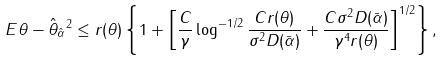Convert formula to latex. <formula><loc_0><loc_0><loc_500><loc_500>E \| \theta - \hat { \theta } _ { \hat { \alpha } } \| ^ { 2 } \leq r ( \theta ) \left \{ 1 + \left [ \frac { C } { \gamma } \log ^ { - 1 / 2 } \frac { C r ( \theta ) } { \sigma ^ { 2 } D ( \bar { \alpha } ) } + \frac { C \sigma ^ { 2 } D ( \bar { \alpha } ) } { \gamma ^ { 4 } r ( \theta ) } \right ] ^ { 1 / 2 } \right \} ,</formula> 